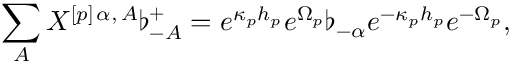Convert formula to latex. <formula><loc_0><loc_0><loc_500><loc_500>\sum _ { A } X ^ { [ p ] \, \alpha , \, A } \flat _ { - A } ^ { + } = e ^ { \kappa _ { p } h _ { p } } e ^ { \Omega _ { p } } \flat _ { - \alpha } e ^ { - \kappa _ { p } h _ { p } } e ^ { - \Omega _ { p } } ,</formula> 